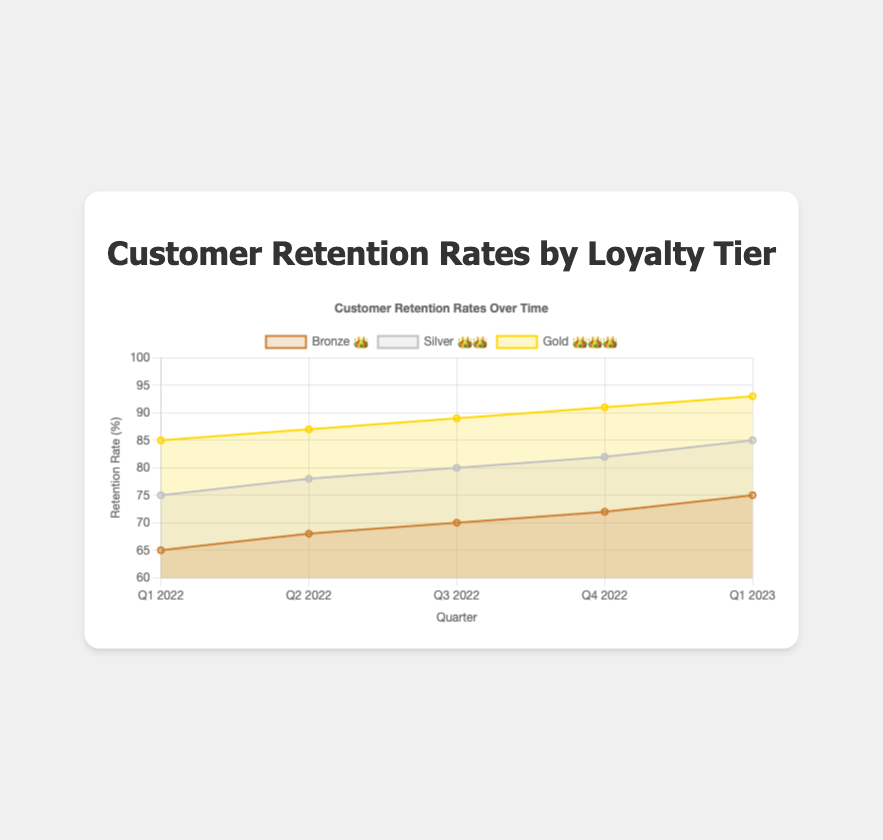What is the retention rate for Bronze 👑 in Q1 2022? The retention rate for the Bronze 👑 tier in Q1 2022 is displayed on the chart at the very beginning of the Bronze series.
Answer: 65% What is the trend of the retention rate for the Silver 👑👑 tier over the given time frames? The trend is observed by looking at the data points for the Silver 👑👑 tier across the time frames. The retention rate increases from Q1 2022 to Q1 2023.
Answer: Increasing Which tier had the highest retention rate in Q4 2022? By comparing the data points for each tier in Q4 2022, we see that the highest retention rate is in the Gold 👑👑👑 tier.
Answer: Gold 👑👑👑 How much did the retention rate for the Gold 👑👑👑 tier increase from Q1 2022 to Q1 2023? The retention rate for Gold 👑👑👑 in Q1 2022 is 85% and in Q1 2023 is 93%. The increase is calculated by subtracting 85% from 93%.
Answer: 8% What is the average retention rate for the Bronze 👑 tier across all given time frames? Sum the retention rates for Bronze 👑 (65 + 68 + 70 + 72 + 75) and divide by the number of time frames (5).
Answer: 70% Which quarter showed the highest overall retention rate when considering all tiers? By examining the data points for all tiers across all quarters, Q1 2023 shows the highest retention rates (75%, 85%, 93% respectively).
Answer: Q1 2023 How does the retention rate for the Silver 👑👑 tier in Q2 2022 compare to the retention rate for the Bronze 👑 tier in the same quarter? The chart shows that in Q2 2022, the Silver 👑👑 tier has a retention rate of 78% and the Bronze 👑 tier has a retention rate of 68%.
Answer: Silver 👑👑 is higher What is the difference in retention rates between the Gold 👑👑👑 and Bronze 👑 tiers in Q3 2022? For Q3 2022, the Gold 👑👑👑 tier has an 89% retention rate and the Bronze 👑 tier has a 70% retention rate. Subtracting 70% from 89% gives the difference.
Answer: 19% Describe the retention rate performance of each tier in Q1 2023. In Q1 2023, the retention rates are 75% for Bronze 👑, 85% for Silver 👑👑, and 93% for Gold 👑👑👑. All tiers show an increasing trend.
Answer: Increasing If a customer moves from the Bronze 👑 tier to the Gold 👑👑👑 tier between Q1 2022 and Q1 2023, how much would their retention rate increase? The retention rate in Q1 2022 for Bronze 👑 is 65% and for Gold 👑👑👑 in Q1 2023 is 93%. The increase is 93% - 65%.
Answer: 28% 